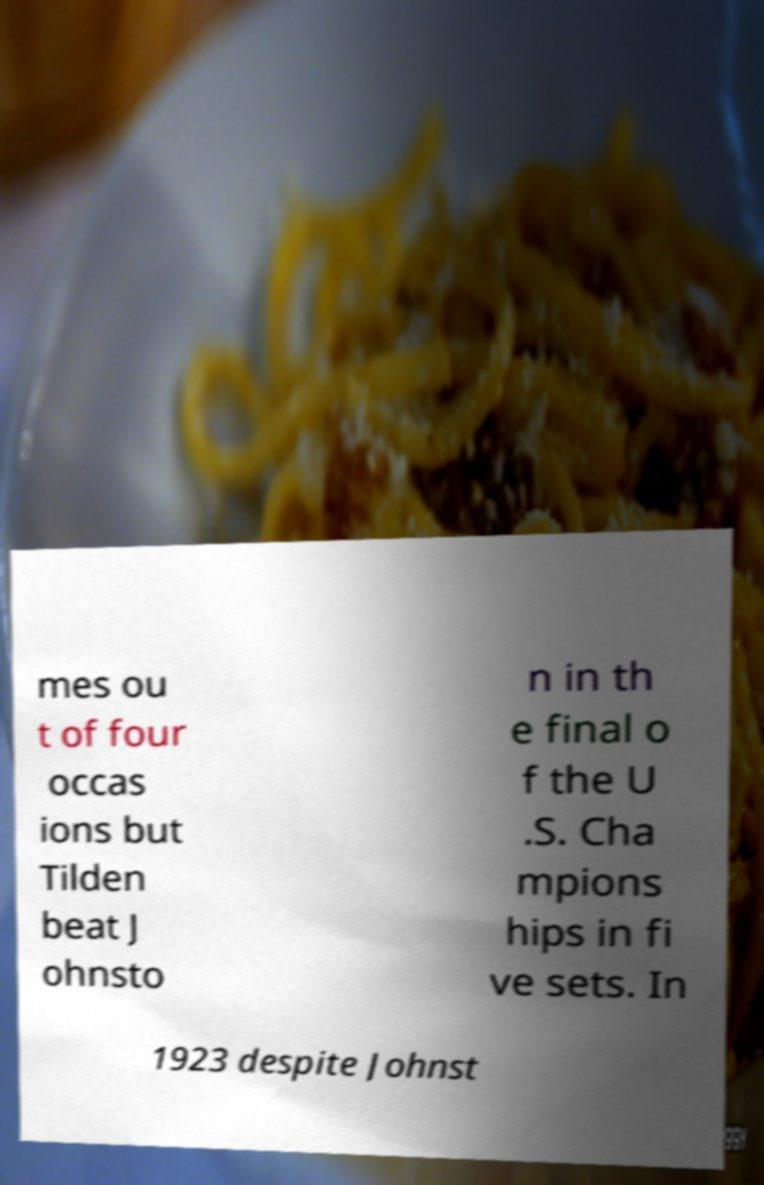Could you extract and type out the text from this image? mes ou t of four occas ions but Tilden beat J ohnsto n in th e final o f the U .S. Cha mpions hips in fi ve sets. In 1923 despite Johnst 